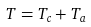<formula> <loc_0><loc_0><loc_500><loc_500>T = T _ { c } + T _ { a }</formula> 